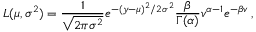Convert formula to latex. <formula><loc_0><loc_0><loc_500><loc_500>L ( \mu , \sigma ^ { 2 } ) = \frac { 1 } { \sqrt { 2 \pi \sigma ^ { 2 } } } e ^ { - ( y - \mu ) ^ { 2 } / 2 \sigma ^ { 2 } } \frac { \beta } { \Gamma ( \alpha ) } v ^ { \alpha - 1 } e ^ { - \beta v } \, ,</formula> 